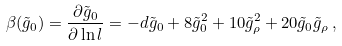Convert formula to latex. <formula><loc_0><loc_0><loc_500><loc_500>\beta ( \tilde { g } _ { 0 } ) = \frac { \partial \tilde { g } _ { 0 } } { \partial \ln l } = - d \tilde { g } _ { 0 } + 8 \tilde { g } _ { 0 } ^ { 2 } + 1 0 \tilde { g } _ { \rho } ^ { 2 } + 2 0 \tilde { g } _ { 0 } \tilde { g } _ { \rho } \, ,</formula> 